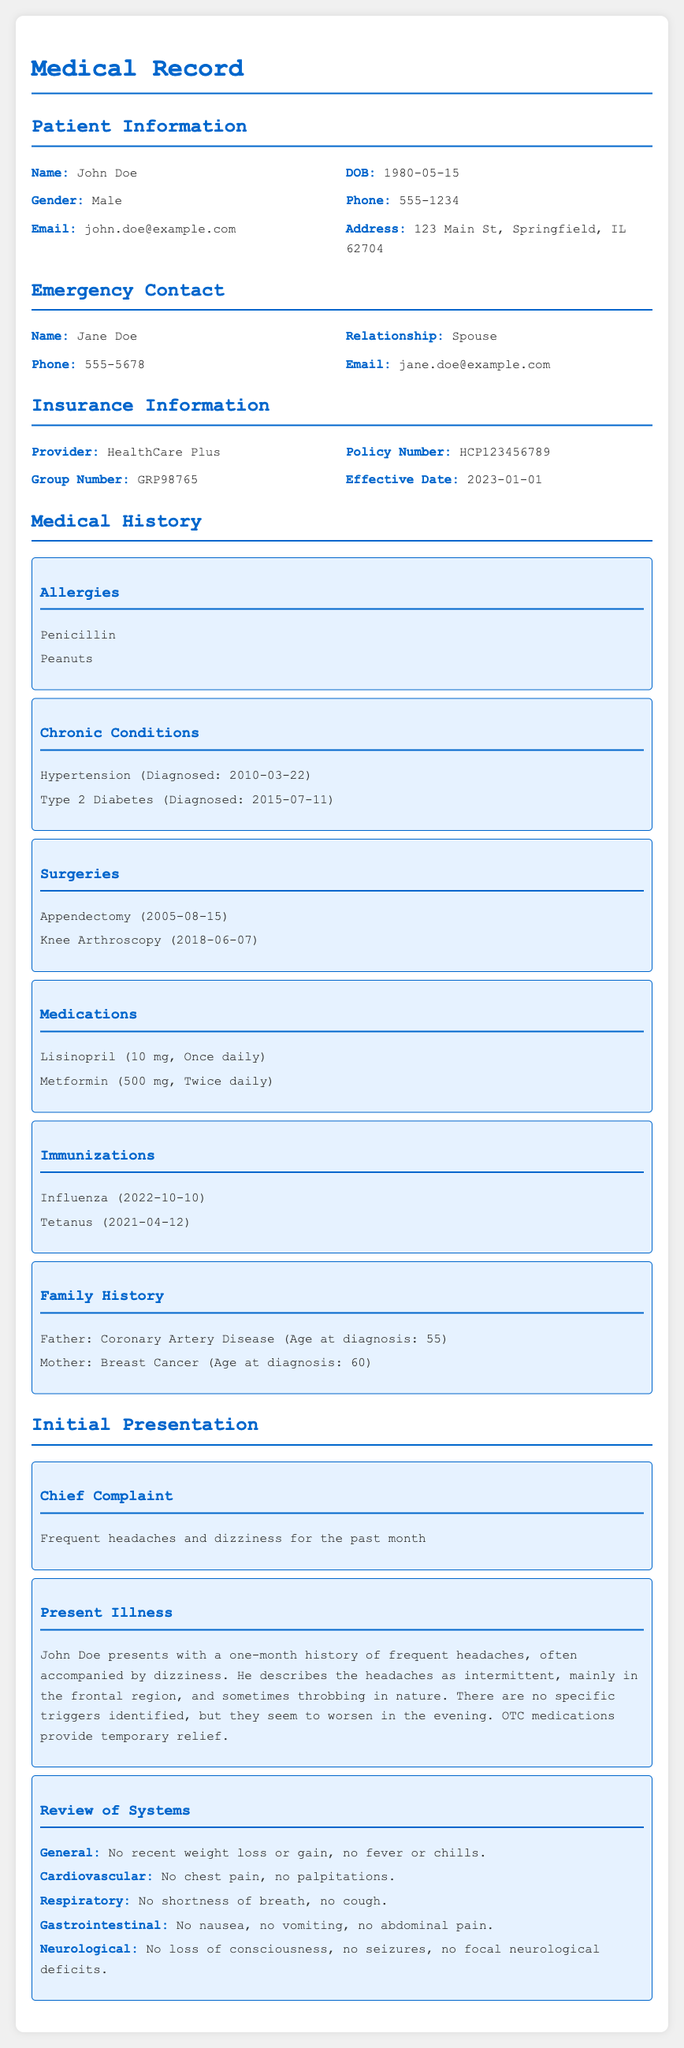What is the patient's name? The patient's name is explicitly stated in the section titled Patient Information.
Answer: John Doe What is the patient's date of birth? The date of birth is found in the Patient Information section, next to the label DOB.
Answer: 1980-05-15 Who is the emergency contact? The emergency contact is listed under the Emergency Contact section.
Answer: Jane Doe What insurance provider does the patient have? The insurance provider is mentioned in the Insurance Information section.
Answer: HealthCare Plus What is the chief complaint of the patient? The chief complaint is outlined in the Initial Presentation section.
Answer: Frequent headaches and dizziness How many chronic conditions does the patient have? The number of chronic conditions can be counted from the Medical History section, specifically the Chronic Conditions part.
Answer: 2 What surgery did the patient have in 2005? The specific surgery is listed within the Surgeries subsection in the Medical History section.
Answer: Appendectomy What medication is prescribed to be taken once daily? This information is available under the Medications subsection of the Medical History section.
Answer: Lisinopril What is the relationship of the emergency contact to the patient? The relationship is stated in the Emergency Contact section.
Answer: Spouse What is the effective date of the patient's insurance? The effective date is specified in the Insurance Information section, next to the label Effective Date.
Answer: 2023-01-01 